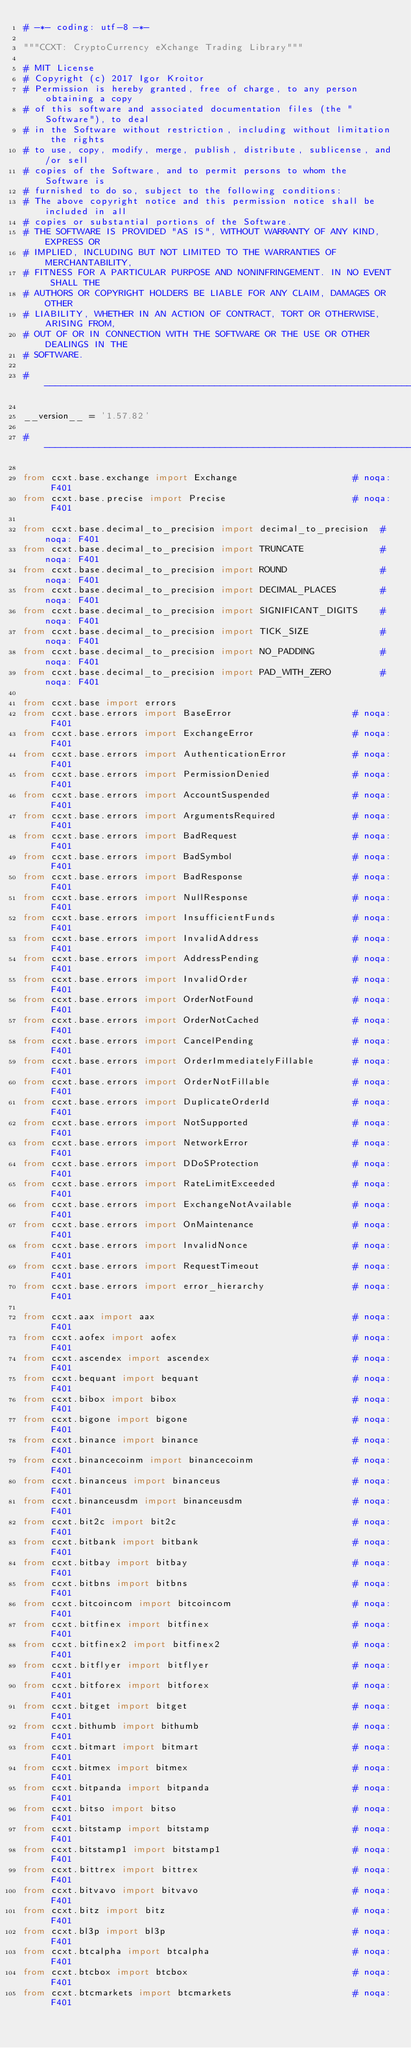Convert code to text. <code><loc_0><loc_0><loc_500><loc_500><_Python_># -*- coding: utf-8 -*-

"""CCXT: CryptoCurrency eXchange Trading Library"""

# MIT License
# Copyright (c) 2017 Igor Kroitor
# Permission is hereby granted, free of charge, to any person obtaining a copy
# of this software and associated documentation files (the "Software"), to deal
# in the Software without restriction, including without limitation the rights
# to use, copy, modify, merge, publish, distribute, sublicense, and/or sell
# copies of the Software, and to permit persons to whom the Software is
# furnished to do so, subject to the following conditions:
# The above copyright notice and this permission notice shall be included in all
# copies or substantial portions of the Software.
# THE SOFTWARE IS PROVIDED "AS IS", WITHOUT WARRANTY OF ANY KIND, EXPRESS OR
# IMPLIED, INCLUDING BUT NOT LIMITED TO THE WARRANTIES OF MERCHANTABILITY,
# FITNESS FOR A PARTICULAR PURPOSE AND NONINFRINGEMENT. IN NO EVENT SHALL THE
# AUTHORS OR COPYRIGHT HOLDERS BE LIABLE FOR ANY CLAIM, DAMAGES OR OTHER
# LIABILITY, WHETHER IN AN ACTION OF CONTRACT, TORT OR OTHERWISE, ARISING FROM,
# OUT OF OR IN CONNECTION WITH THE SOFTWARE OR THE USE OR OTHER DEALINGS IN THE
# SOFTWARE.

# ----------------------------------------------------------------------------

__version__ = '1.57.82'

# ----------------------------------------------------------------------------

from ccxt.base.exchange import Exchange                     # noqa: F401
from ccxt.base.precise import Precise                       # noqa: F401

from ccxt.base.decimal_to_precision import decimal_to_precision  # noqa: F401
from ccxt.base.decimal_to_precision import TRUNCATE              # noqa: F401
from ccxt.base.decimal_to_precision import ROUND                 # noqa: F401
from ccxt.base.decimal_to_precision import DECIMAL_PLACES        # noqa: F401
from ccxt.base.decimal_to_precision import SIGNIFICANT_DIGITS    # noqa: F401
from ccxt.base.decimal_to_precision import TICK_SIZE             # noqa: F401
from ccxt.base.decimal_to_precision import NO_PADDING            # noqa: F401
from ccxt.base.decimal_to_precision import PAD_WITH_ZERO         # noqa: F401

from ccxt.base import errors
from ccxt.base.errors import BaseError                      # noqa: F401
from ccxt.base.errors import ExchangeError                  # noqa: F401
from ccxt.base.errors import AuthenticationError            # noqa: F401
from ccxt.base.errors import PermissionDenied               # noqa: F401
from ccxt.base.errors import AccountSuspended               # noqa: F401
from ccxt.base.errors import ArgumentsRequired              # noqa: F401
from ccxt.base.errors import BadRequest                     # noqa: F401
from ccxt.base.errors import BadSymbol                      # noqa: F401
from ccxt.base.errors import BadResponse                    # noqa: F401
from ccxt.base.errors import NullResponse                   # noqa: F401
from ccxt.base.errors import InsufficientFunds              # noqa: F401
from ccxt.base.errors import InvalidAddress                 # noqa: F401
from ccxt.base.errors import AddressPending                 # noqa: F401
from ccxt.base.errors import InvalidOrder                   # noqa: F401
from ccxt.base.errors import OrderNotFound                  # noqa: F401
from ccxt.base.errors import OrderNotCached                 # noqa: F401
from ccxt.base.errors import CancelPending                  # noqa: F401
from ccxt.base.errors import OrderImmediatelyFillable       # noqa: F401
from ccxt.base.errors import OrderNotFillable               # noqa: F401
from ccxt.base.errors import DuplicateOrderId               # noqa: F401
from ccxt.base.errors import NotSupported                   # noqa: F401
from ccxt.base.errors import NetworkError                   # noqa: F401
from ccxt.base.errors import DDoSProtection                 # noqa: F401
from ccxt.base.errors import RateLimitExceeded              # noqa: F401
from ccxt.base.errors import ExchangeNotAvailable           # noqa: F401
from ccxt.base.errors import OnMaintenance                  # noqa: F401
from ccxt.base.errors import InvalidNonce                   # noqa: F401
from ccxt.base.errors import RequestTimeout                 # noqa: F401
from ccxt.base.errors import error_hierarchy                # noqa: F401

from ccxt.aax import aax                                    # noqa: F401
from ccxt.aofex import aofex                                # noqa: F401
from ccxt.ascendex import ascendex                          # noqa: F401
from ccxt.bequant import bequant                            # noqa: F401
from ccxt.bibox import bibox                                # noqa: F401
from ccxt.bigone import bigone                              # noqa: F401
from ccxt.binance import binance                            # noqa: F401
from ccxt.binancecoinm import binancecoinm                  # noqa: F401
from ccxt.binanceus import binanceus                        # noqa: F401
from ccxt.binanceusdm import binanceusdm                    # noqa: F401
from ccxt.bit2c import bit2c                                # noqa: F401
from ccxt.bitbank import bitbank                            # noqa: F401
from ccxt.bitbay import bitbay                              # noqa: F401
from ccxt.bitbns import bitbns                              # noqa: F401
from ccxt.bitcoincom import bitcoincom                      # noqa: F401
from ccxt.bitfinex import bitfinex                          # noqa: F401
from ccxt.bitfinex2 import bitfinex2                        # noqa: F401
from ccxt.bitflyer import bitflyer                          # noqa: F401
from ccxt.bitforex import bitforex                          # noqa: F401
from ccxt.bitget import bitget                              # noqa: F401
from ccxt.bithumb import bithumb                            # noqa: F401
from ccxt.bitmart import bitmart                            # noqa: F401
from ccxt.bitmex import bitmex                              # noqa: F401
from ccxt.bitpanda import bitpanda                          # noqa: F401
from ccxt.bitso import bitso                                # noqa: F401
from ccxt.bitstamp import bitstamp                          # noqa: F401
from ccxt.bitstamp1 import bitstamp1                        # noqa: F401
from ccxt.bittrex import bittrex                            # noqa: F401
from ccxt.bitvavo import bitvavo                            # noqa: F401
from ccxt.bitz import bitz                                  # noqa: F401
from ccxt.bl3p import bl3p                                  # noqa: F401
from ccxt.btcalpha import btcalpha                          # noqa: F401
from ccxt.btcbox import btcbox                              # noqa: F401
from ccxt.btcmarkets import btcmarkets                      # noqa: F401</code> 